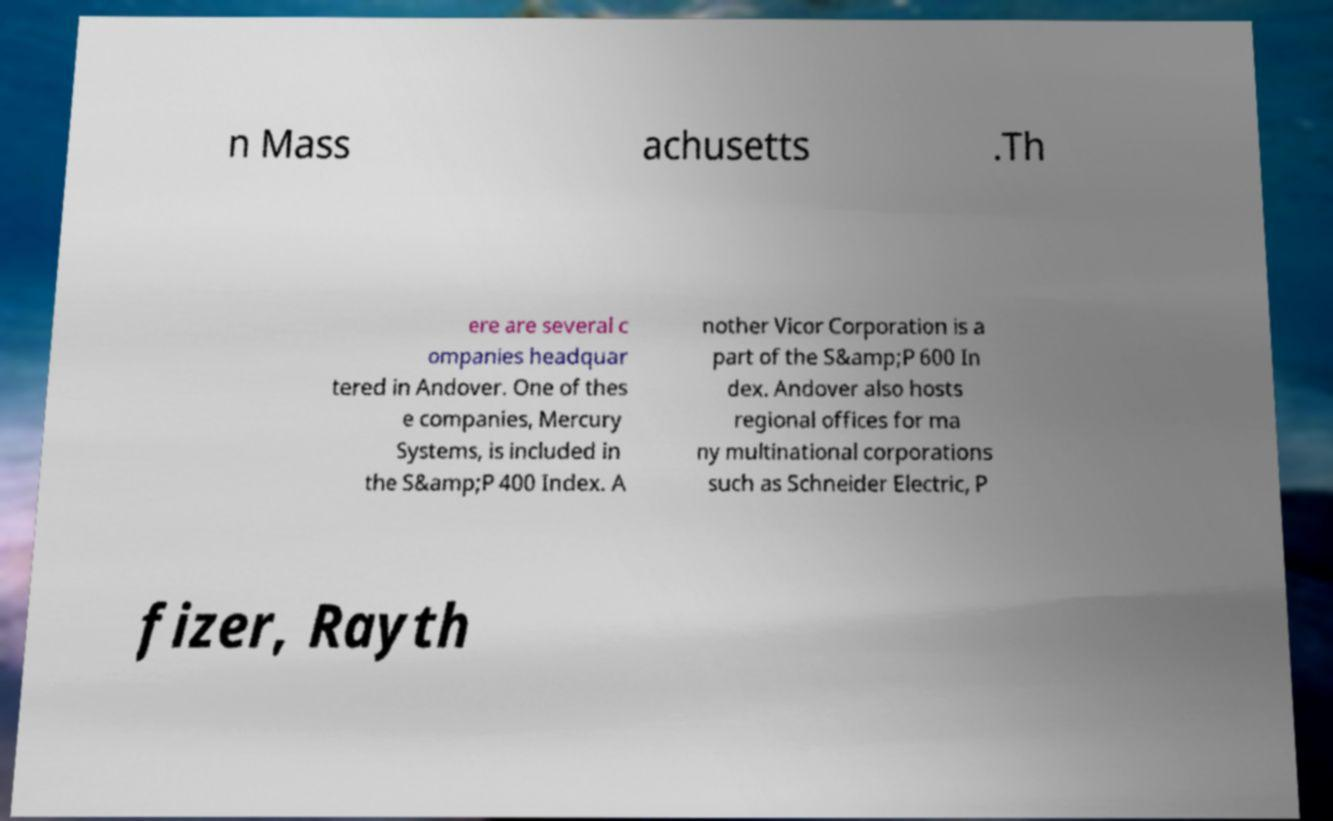Can you read and provide the text displayed in the image?This photo seems to have some interesting text. Can you extract and type it out for me? n Mass achusetts .Th ere are several c ompanies headquar tered in Andover. One of thes e companies, Mercury Systems, is included in the S&amp;P 400 Index. A nother Vicor Corporation is a part of the S&amp;P 600 In dex. Andover also hosts regional offices for ma ny multinational corporations such as Schneider Electric, P fizer, Rayth 